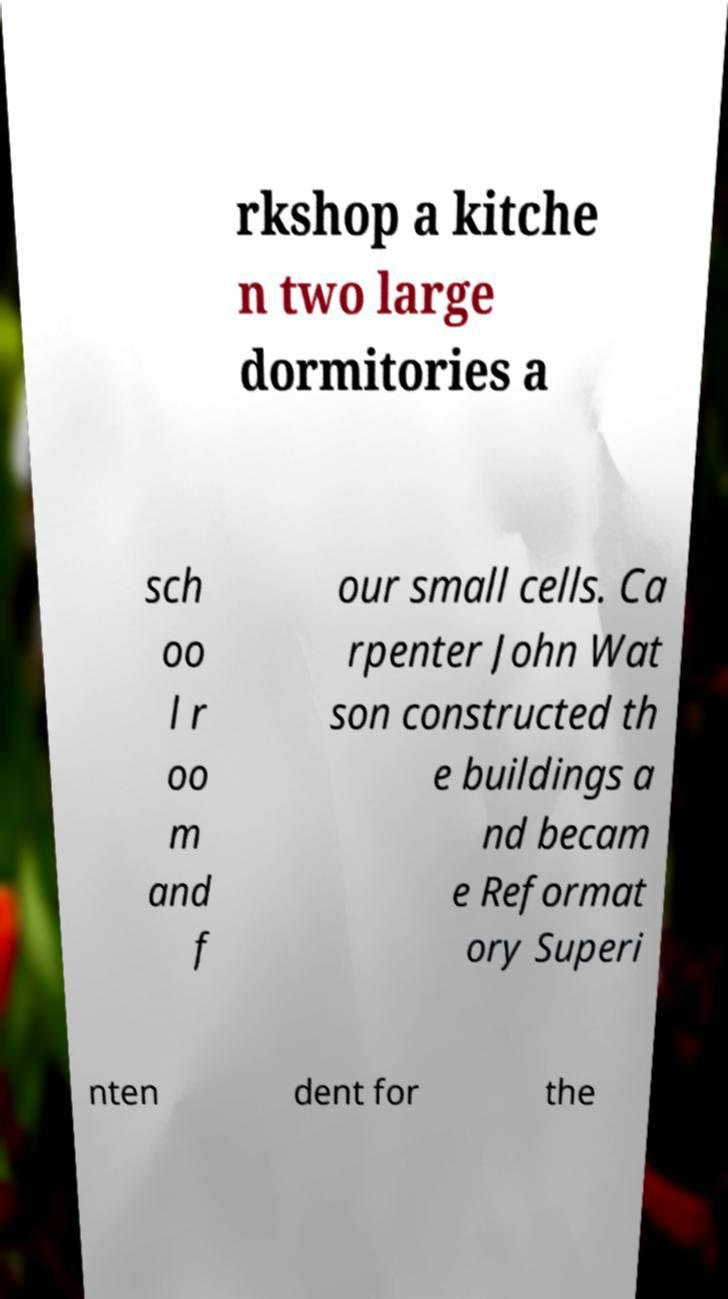There's text embedded in this image that I need extracted. Can you transcribe it verbatim? rkshop a kitche n two large dormitories a sch oo l r oo m and f our small cells. Ca rpenter John Wat son constructed th e buildings a nd becam e Reformat ory Superi nten dent for the 